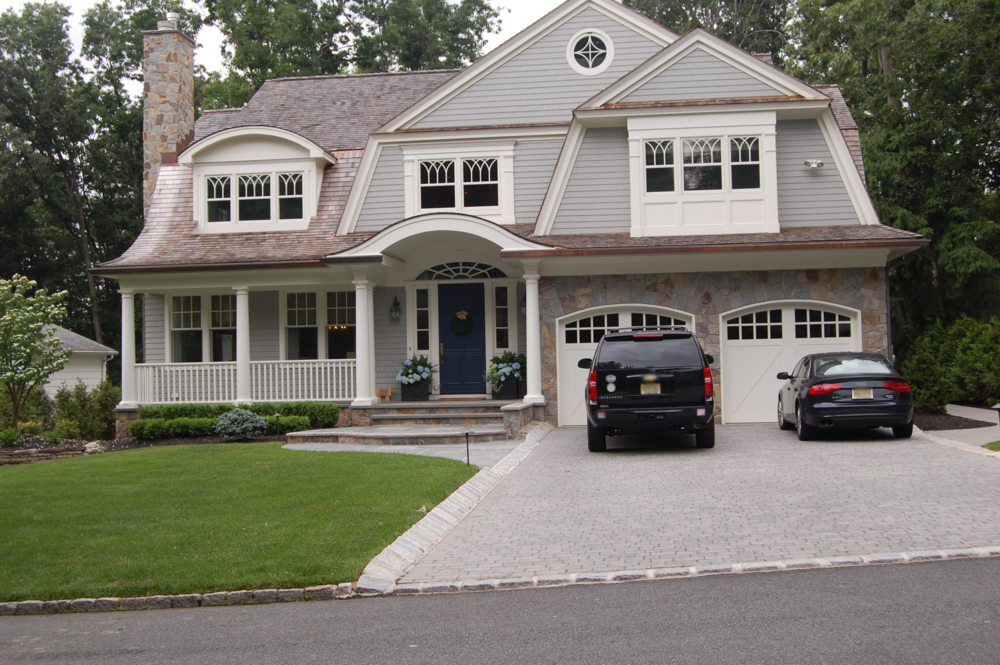How might this house look during the holiday season? During the holiday season, this Craftsman-style house could be transformed into a festive wonderland. Twinkling lights would frame the roofline, windows, and wrap-around porch, creating a warm and inviting glow. A grand wreath with red ribbons might adorn the front door, and the porch could feature potted poinsettias and holiday-themed decorations. Inside, the living room would be the heart of the festive decor, with a beautifully decorated Christmas tree or other seasonal centerpiece taking pride of place. Stockings would hang from the mantle, and garlands would add a touch of greenery. The kitchen would be bustling with the preparation of holiday feasts, and the dining room might have a table set with elegant dishes, candles, and festive centerpieces, ready for a family gathering. On the lawn, perhaps a few illuminated reindeer or snowmen might greet visitors. This house would truly embody the spirit and warmth of the holiday season, making it a magical place for family and friends to celebrate together. What kind of activities might the family enjoy during the holiday season in this house? During the holiday season, the family residing in this inviting house might engage in a variety of festive activities. They could start with decorating the house together, hanging ornaments on the Christmas tree, and setting up holiday lights outside. Baking cookies and preparing holiday treats in the cozy kitchen would be another highlight, filling the house with delightful aromas. Evenings could be spent by the fireplace, sipping hot cocoa and sharing stories or watching holiday classics on TV. The wrap-around porch offers a perfect spot for outdoor activities like making snowmen or having snowball fights if there is snow. Wrapping gifts and preparing for holiday gatherings would bring joy and anticipation. Hosting family dinners and inviting friends over for holiday parties would create lasting memories, all within the warm, festive ambiance of their beautifully decorated home. 